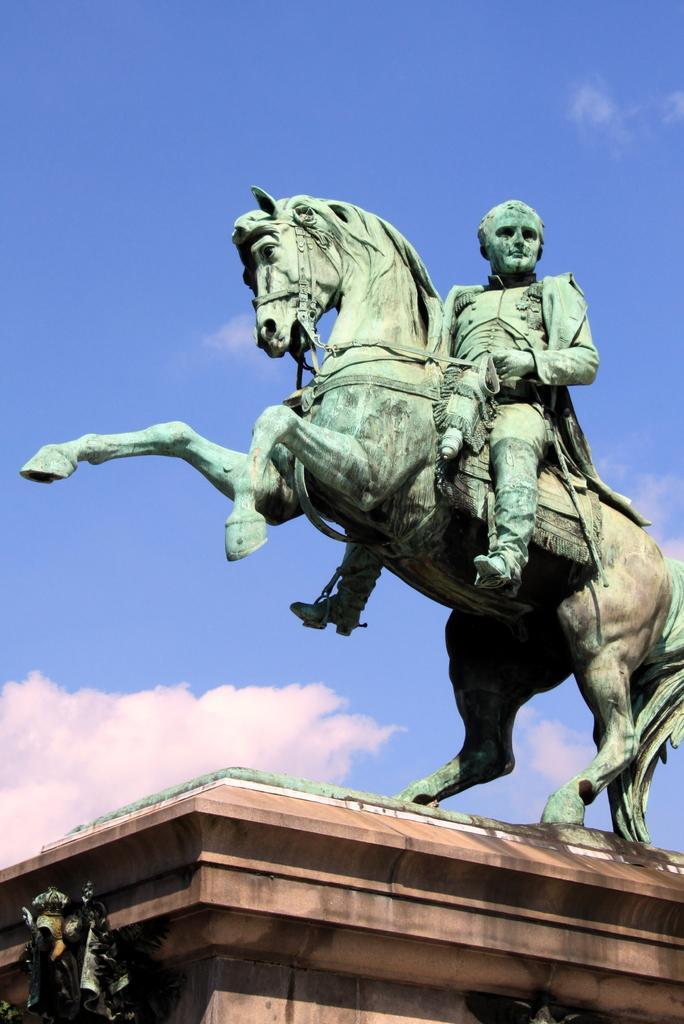Describe this image in one or two sentences. In this image I see a statue of a horse and a person sitting on it and I see that this statue is on this brown color thing and I see the sky in the background. 